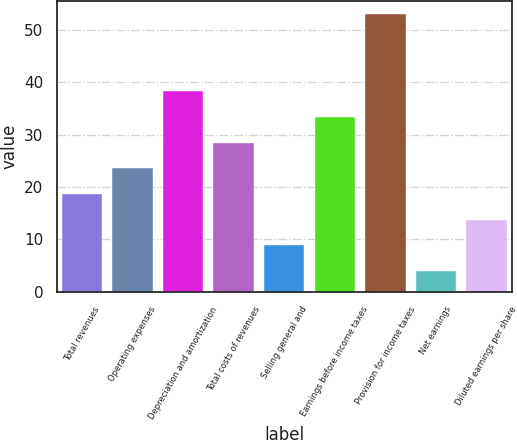<chart> <loc_0><loc_0><loc_500><loc_500><bar_chart><fcel>Total revenues<fcel>Operating expenses<fcel>Depreciation and amortization<fcel>Total costs of revenues<fcel>Selling general and<fcel>Earnings before income taxes<fcel>Provision for income taxes<fcel>Net earnings<fcel>Diluted earnings per share<nl><fcel>18.7<fcel>23.6<fcel>38.3<fcel>28.5<fcel>8.9<fcel>33.4<fcel>53<fcel>4<fcel>13.8<nl></chart> 